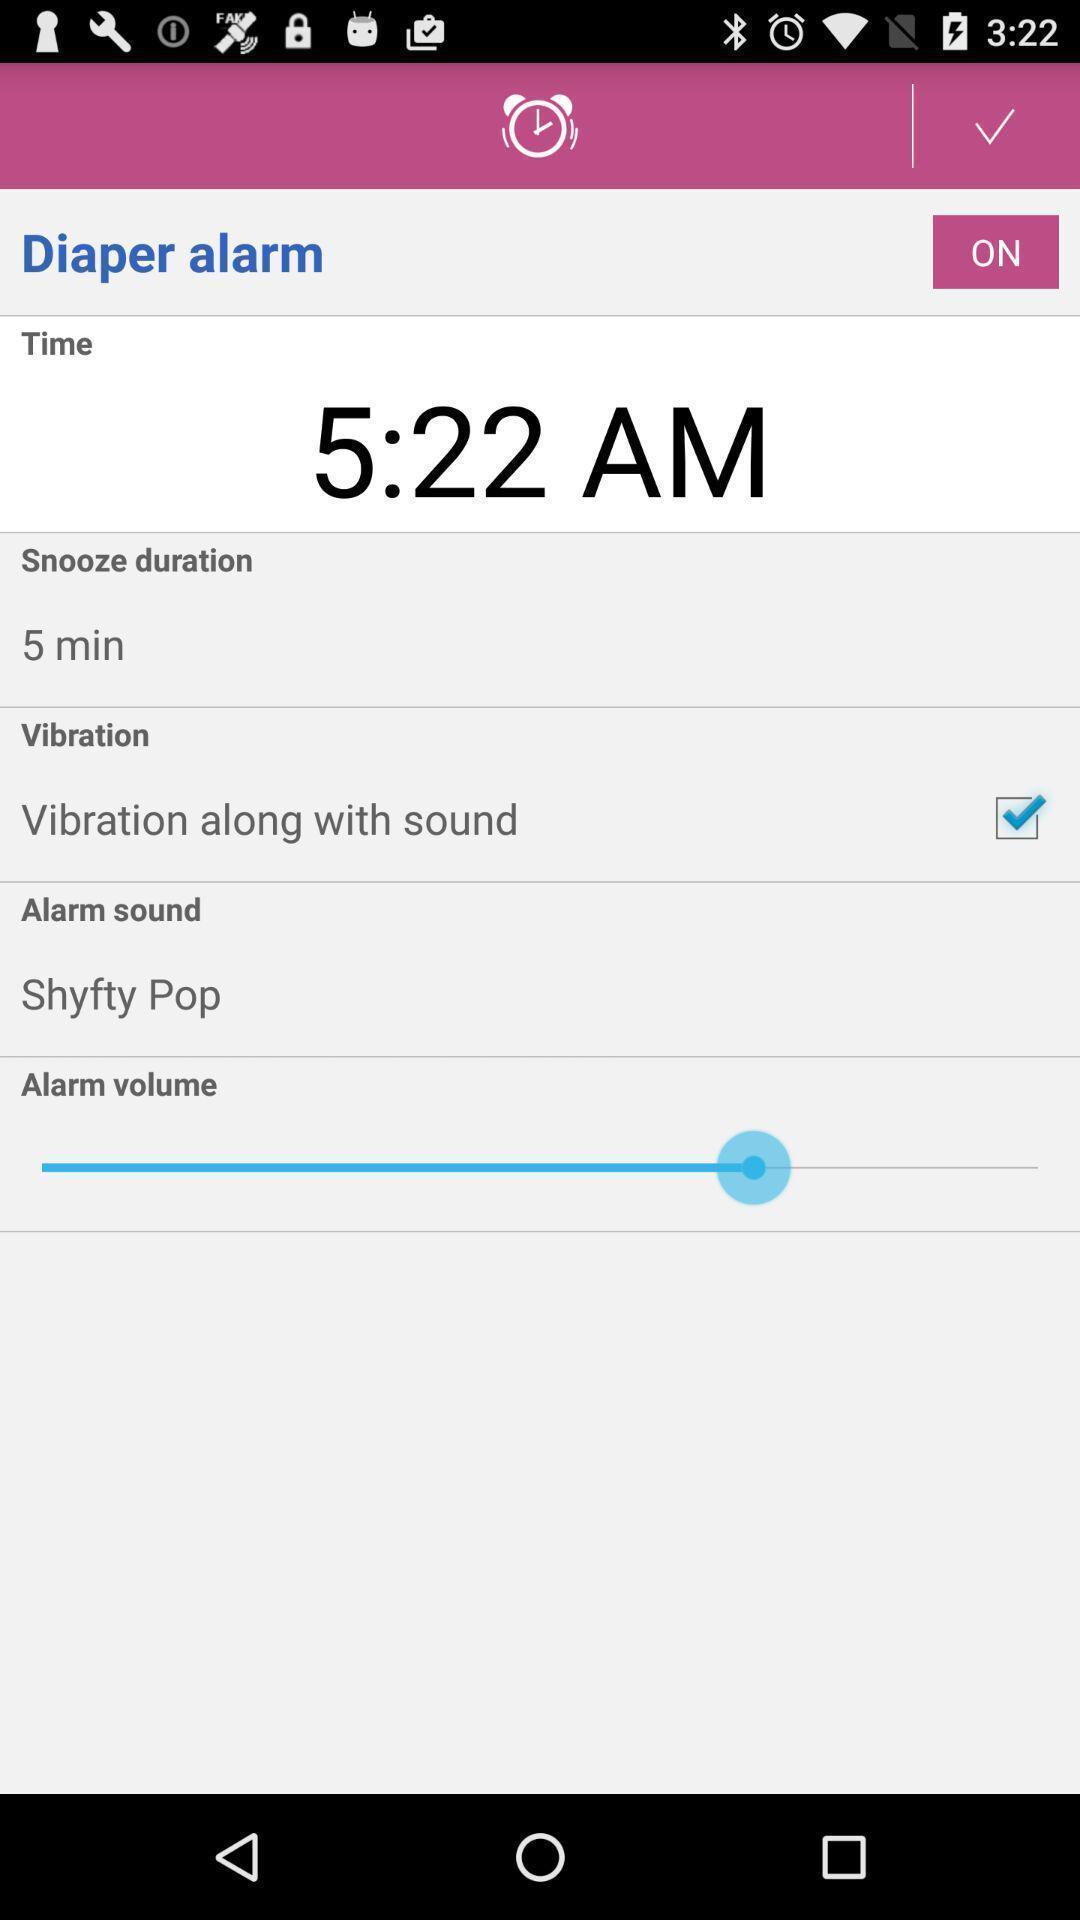Describe this image in words. Window displaying a alarm page. 